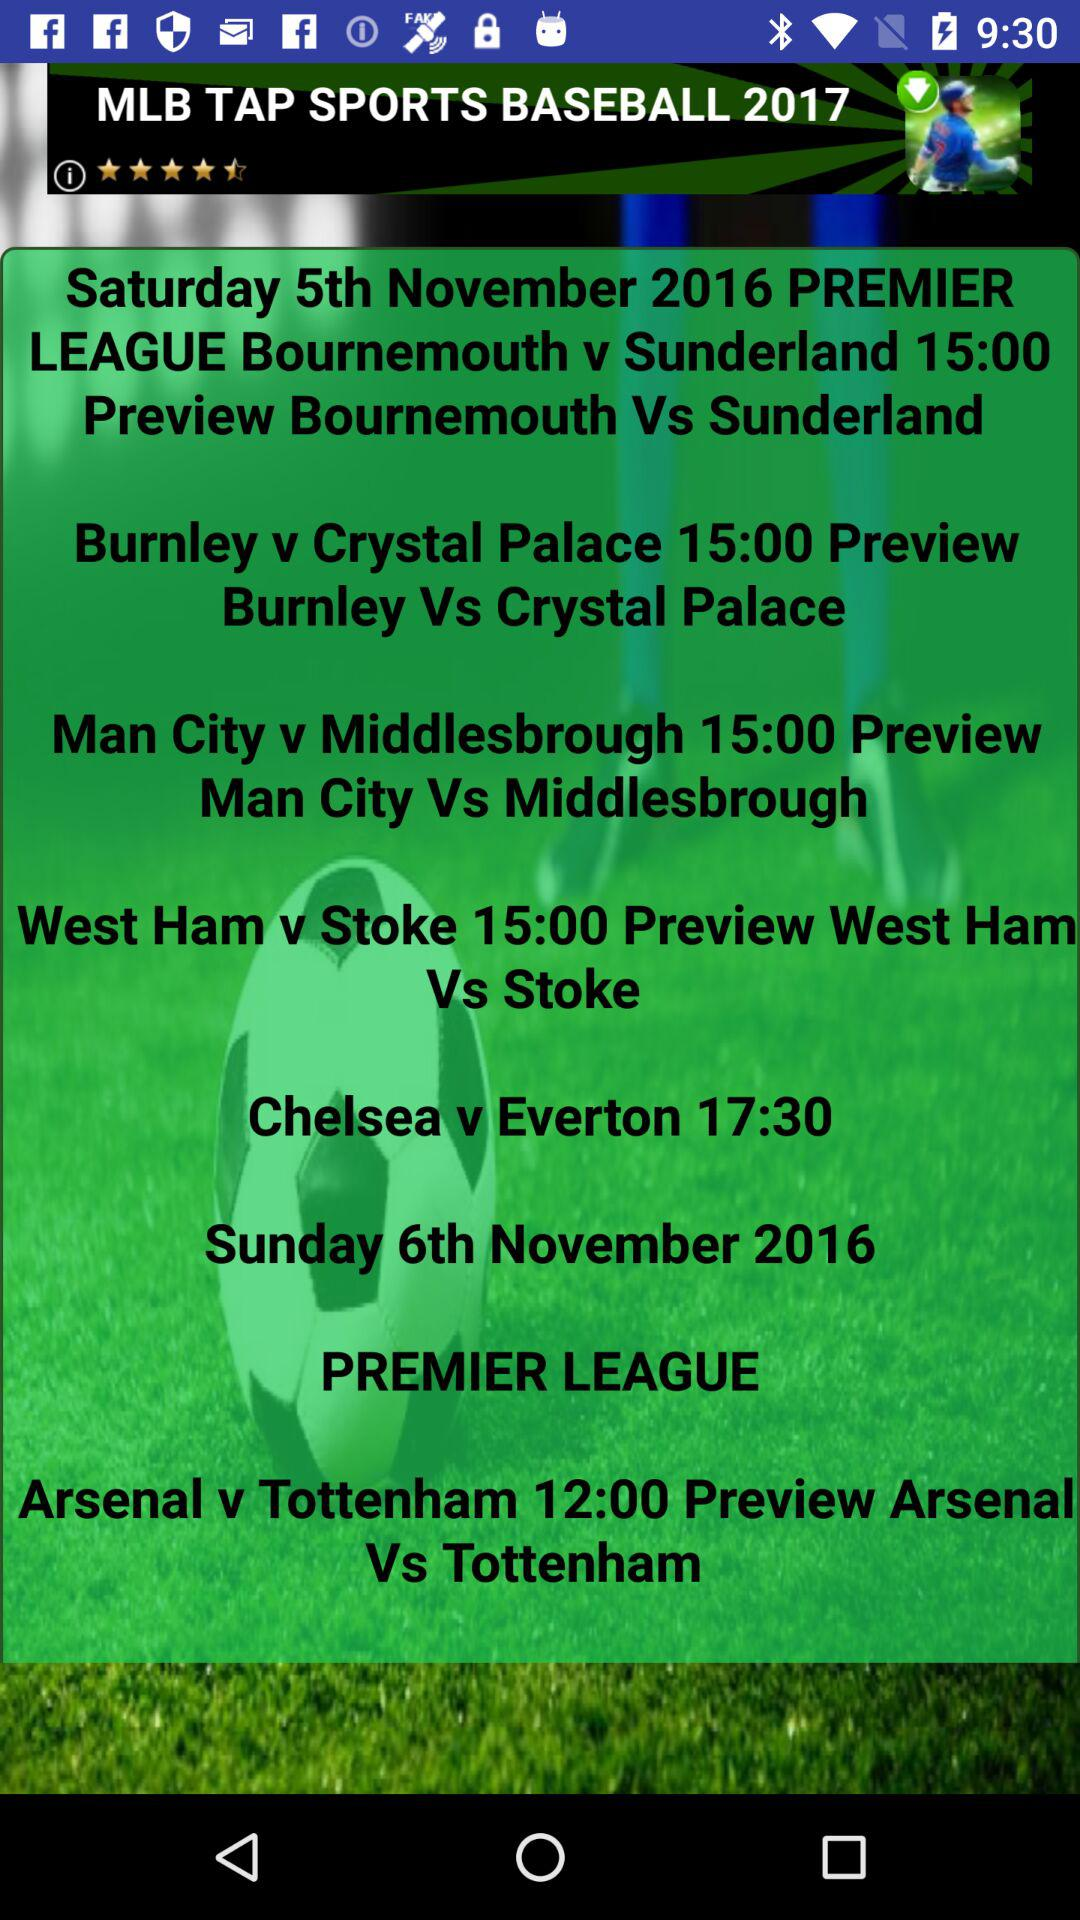What is the timing of the Chelsea vs Everton match? The time of the match is 17:30. 